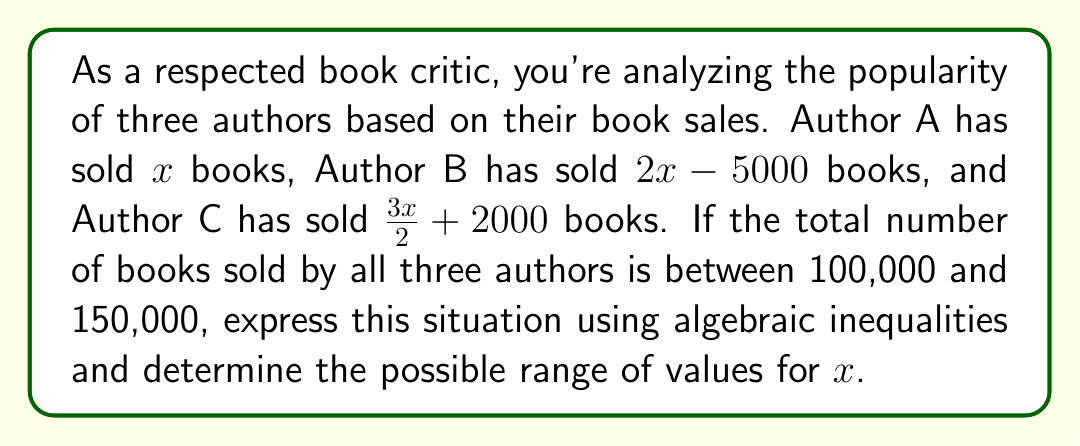Can you solve this math problem? Let's approach this step-by-step:

1) First, we need to express the total number of books sold by all three authors:
   Total = Author A + Author B + Author C
   $$ x + (2x - 5000) + (\frac{3x}{2} + 2000) $$

2) Simplify this expression:
   $$ x + 2x - 5000 + \frac{3x}{2} + 2000 $$
   $$ = x + 2x + \frac{3x}{2} - 3000 $$
   $$ = \frac{2x}{2} + \frac{4x}{2} + \frac{3x}{2} - 3000 $$
   $$ = \frac{9x}{2} - 3000 $$

3) Now, we can set up the inequality based on the given information:
   $$ 100,000 < \frac{9x}{2} - 3000 < 150,000 $$

4) Let's solve for $x$. First, add 3000 to all parts of the inequality:
   $$ 103,000 < \frac{9x}{2} < 153,000 $$

5) Now, multiply all parts by 2:
   $$ 206,000 < 9x < 306,000 $$

6) Finally, divide all parts by 9:
   $$ \frac{206,000}{9} < x < \frac{306,000}{9} $$

7) Simplify:
   $$ 22,888.89 < x < 34,000 $$

8) Since $x$ represents the number of books and must be a whole number, we can round these bounds to the nearest integer:
   $$ 22,889 \leq x \leq 34,000 $$
Answer: The possible range of values for $x$ is $22,889 \leq x \leq 34,000$. 